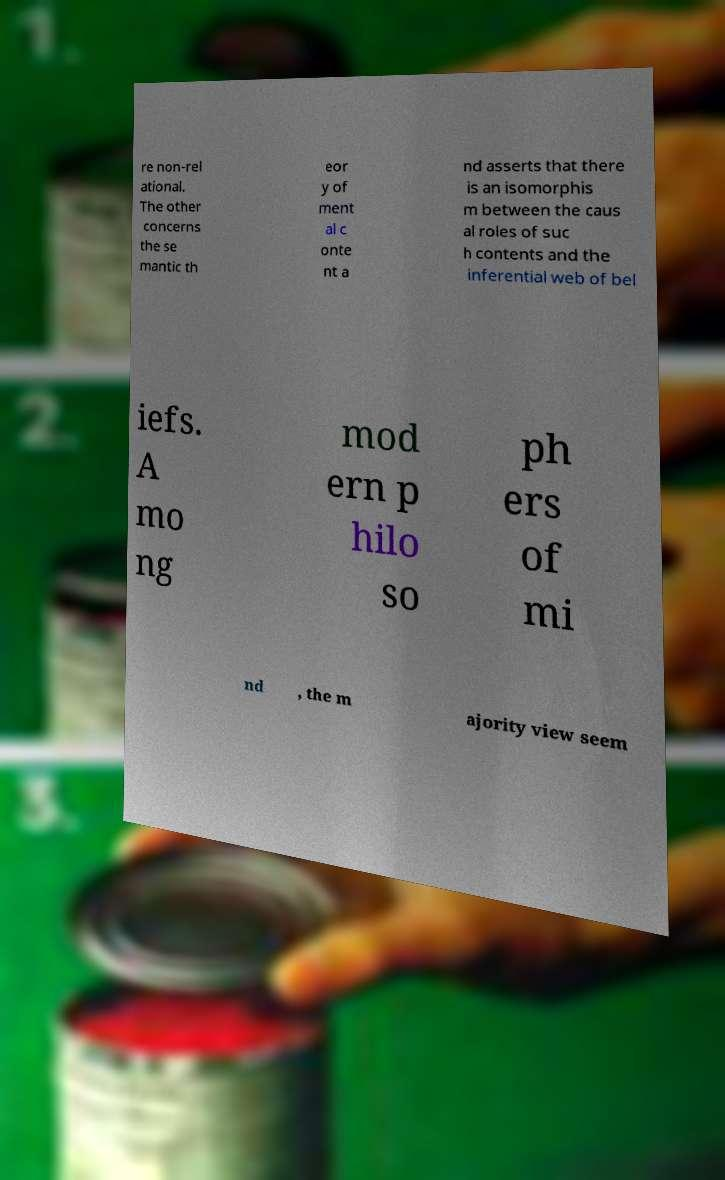I need the written content from this picture converted into text. Can you do that? re non-rel ational. The other concerns the se mantic th eor y of ment al c onte nt a nd asserts that there is an isomorphis m between the caus al roles of suc h contents and the inferential web of bel iefs. A mo ng mod ern p hilo so ph ers of mi nd , the m ajority view seem 